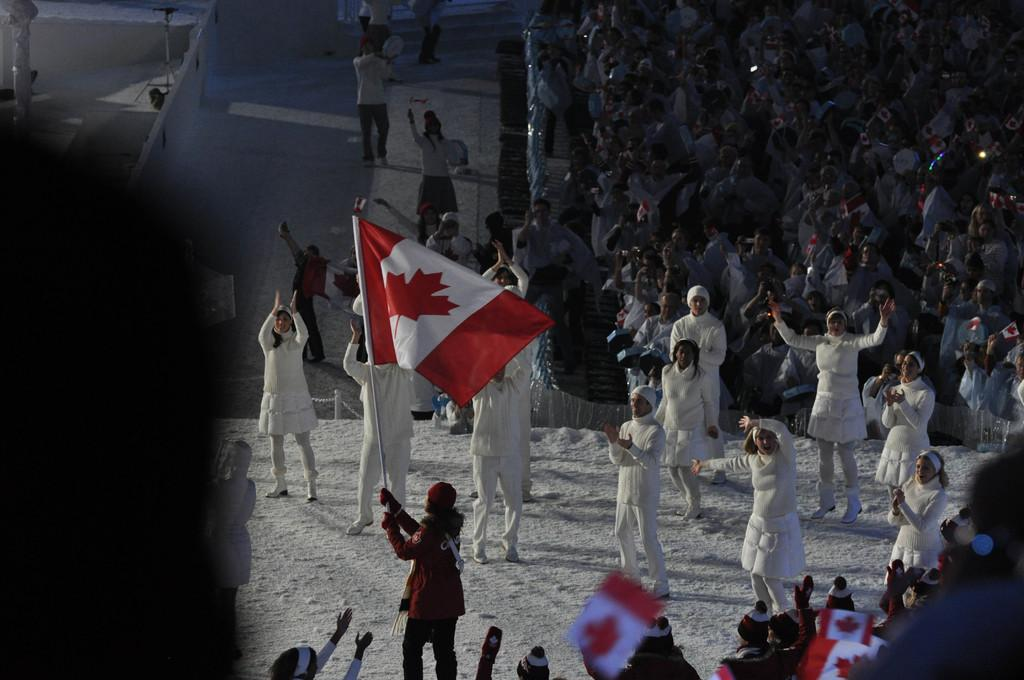What is happening in the image involving multiple people? There is a group of people in the image, with some standing and some walking. Are there any objects or items being held by the people in the image? Yes, there are people holding flags in their hands. How many geese are flying in the image? There are no geese present in the image. What type of work are the people in the image doing? The provided facts do not mention any specific work being done by the people in the image. 